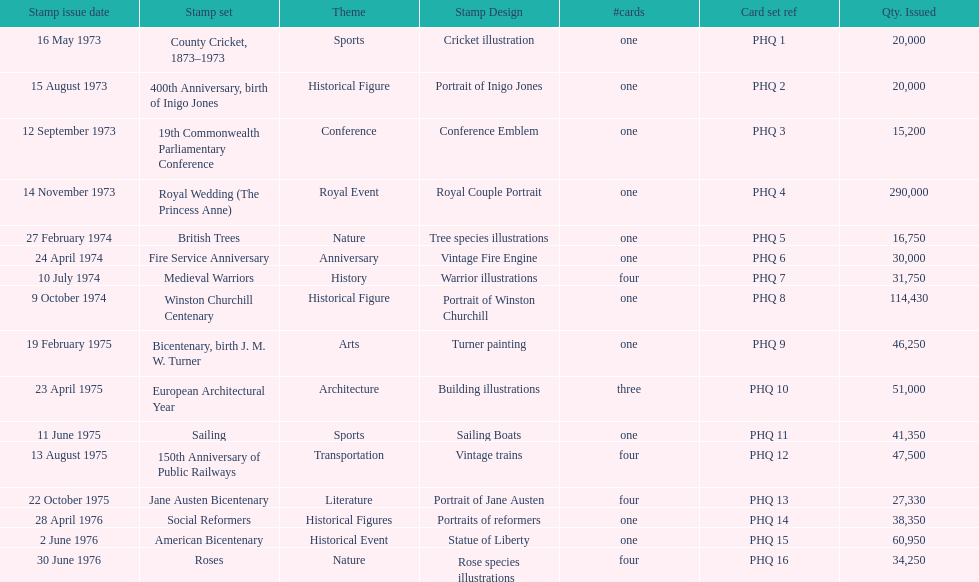Which was the only stamp set to have more than 200,000 issued? Royal Wedding (The Princess Anne). 